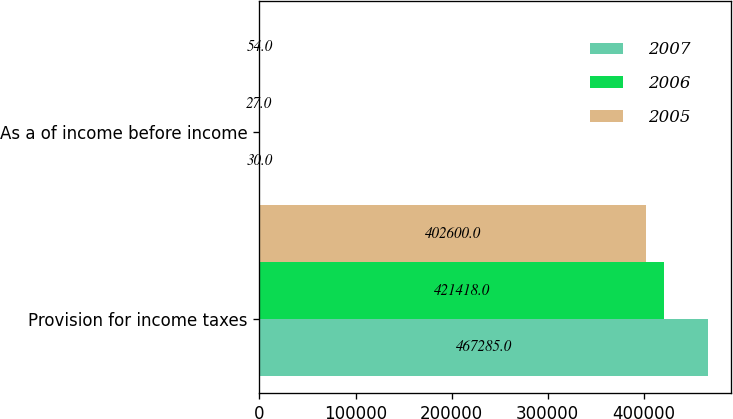<chart> <loc_0><loc_0><loc_500><loc_500><stacked_bar_chart><ecel><fcel>Provision for income taxes<fcel>As a of income before income<nl><fcel>2007<fcel>467285<fcel>30<nl><fcel>2006<fcel>421418<fcel>27<nl><fcel>2005<fcel>402600<fcel>54<nl></chart> 